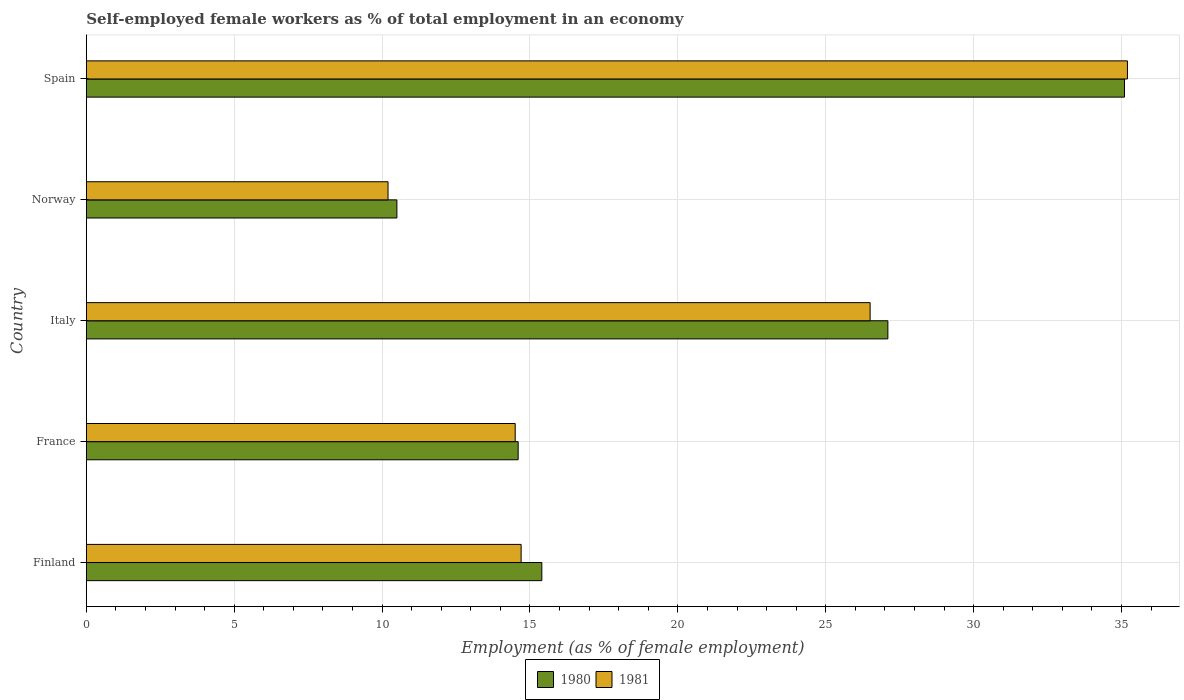How many different coloured bars are there?
Keep it short and to the point. 2. How many bars are there on the 3rd tick from the bottom?
Give a very brief answer. 2. What is the label of the 2nd group of bars from the top?
Give a very brief answer. Norway. In how many cases, is the number of bars for a given country not equal to the number of legend labels?
Your answer should be very brief. 0. What is the percentage of self-employed female workers in 1980 in Finland?
Keep it short and to the point. 15.4. Across all countries, what is the maximum percentage of self-employed female workers in 1981?
Your answer should be very brief. 35.2. Across all countries, what is the minimum percentage of self-employed female workers in 1981?
Provide a succinct answer. 10.2. In which country was the percentage of self-employed female workers in 1980 maximum?
Make the answer very short. Spain. In which country was the percentage of self-employed female workers in 1980 minimum?
Provide a short and direct response. Norway. What is the total percentage of self-employed female workers in 1980 in the graph?
Offer a very short reply. 102.7. What is the difference between the percentage of self-employed female workers in 1980 in France and that in Spain?
Your answer should be very brief. -20.5. What is the difference between the percentage of self-employed female workers in 1981 in Spain and the percentage of self-employed female workers in 1980 in Italy?
Make the answer very short. 8.1. What is the average percentage of self-employed female workers in 1981 per country?
Ensure brevity in your answer.  20.22. What is the difference between the percentage of self-employed female workers in 1980 and percentage of self-employed female workers in 1981 in Italy?
Your answer should be compact. 0.6. What is the ratio of the percentage of self-employed female workers in 1980 in Finland to that in Norway?
Provide a short and direct response. 1.47. Is the difference between the percentage of self-employed female workers in 1980 in France and Spain greater than the difference between the percentage of self-employed female workers in 1981 in France and Spain?
Keep it short and to the point. Yes. What is the difference between the highest and the second highest percentage of self-employed female workers in 1981?
Give a very brief answer. 8.7. What is the difference between the highest and the lowest percentage of self-employed female workers in 1981?
Your answer should be compact. 25. Is the sum of the percentage of self-employed female workers in 1981 in Finland and Italy greater than the maximum percentage of self-employed female workers in 1980 across all countries?
Your answer should be very brief. Yes. What does the 1st bar from the bottom in Italy represents?
Provide a short and direct response. 1980. How many bars are there?
Your answer should be compact. 10. Are all the bars in the graph horizontal?
Make the answer very short. Yes. How many countries are there in the graph?
Offer a terse response. 5. What is the difference between two consecutive major ticks on the X-axis?
Keep it short and to the point. 5. Are the values on the major ticks of X-axis written in scientific E-notation?
Keep it short and to the point. No. How are the legend labels stacked?
Offer a very short reply. Horizontal. What is the title of the graph?
Provide a succinct answer. Self-employed female workers as % of total employment in an economy. Does "1988" appear as one of the legend labels in the graph?
Your response must be concise. No. What is the label or title of the X-axis?
Keep it short and to the point. Employment (as % of female employment). What is the Employment (as % of female employment) of 1980 in Finland?
Your answer should be compact. 15.4. What is the Employment (as % of female employment) of 1981 in Finland?
Keep it short and to the point. 14.7. What is the Employment (as % of female employment) of 1980 in France?
Ensure brevity in your answer.  14.6. What is the Employment (as % of female employment) in 1980 in Italy?
Provide a short and direct response. 27.1. What is the Employment (as % of female employment) of 1981 in Italy?
Ensure brevity in your answer.  26.5. What is the Employment (as % of female employment) of 1980 in Norway?
Provide a succinct answer. 10.5. What is the Employment (as % of female employment) in 1981 in Norway?
Provide a short and direct response. 10.2. What is the Employment (as % of female employment) in 1980 in Spain?
Your answer should be very brief. 35.1. What is the Employment (as % of female employment) in 1981 in Spain?
Offer a very short reply. 35.2. Across all countries, what is the maximum Employment (as % of female employment) in 1980?
Ensure brevity in your answer.  35.1. Across all countries, what is the maximum Employment (as % of female employment) of 1981?
Your response must be concise. 35.2. Across all countries, what is the minimum Employment (as % of female employment) of 1980?
Ensure brevity in your answer.  10.5. Across all countries, what is the minimum Employment (as % of female employment) in 1981?
Keep it short and to the point. 10.2. What is the total Employment (as % of female employment) of 1980 in the graph?
Your answer should be compact. 102.7. What is the total Employment (as % of female employment) in 1981 in the graph?
Provide a succinct answer. 101.1. What is the difference between the Employment (as % of female employment) of 1980 in Finland and that in Spain?
Offer a terse response. -19.7. What is the difference between the Employment (as % of female employment) in 1981 in Finland and that in Spain?
Your answer should be very brief. -20.5. What is the difference between the Employment (as % of female employment) of 1980 in France and that in Italy?
Your answer should be compact. -12.5. What is the difference between the Employment (as % of female employment) in 1981 in France and that in Norway?
Your response must be concise. 4.3. What is the difference between the Employment (as % of female employment) in 1980 in France and that in Spain?
Make the answer very short. -20.5. What is the difference between the Employment (as % of female employment) of 1981 in France and that in Spain?
Offer a very short reply. -20.7. What is the difference between the Employment (as % of female employment) of 1980 in Italy and that in Spain?
Offer a terse response. -8. What is the difference between the Employment (as % of female employment) in 1980 in Norway and that in Spain?
Your answer should be compact. -24.6. What is the difference between the Employment (as % of female employment) in 1981 in Norway and that in Spain?
Provide a succinct answer. -25. What is the difference between the Employment (as % of female employment) of 1980 in Finland and the Employment (as % of female employment) of 1981 in France?
Offer a terse response. 0.9. What is the difference between the Employment (as % of female employment) of 1980 in Finland and the Employment (as % of female employment) of 1981 in Norway?
Provide a short and direct response. 5.2. What is the difference between the Employment (as % of female employment) in 1980 in Finland and the Employment (as % of female employment) in 1981 in Spain?
Give a very brief answer. -19.8. What is the difference between the Employment (as % of female employment) in 1980 in France and the Employment (as % of female employment) in 1981 in Norway?
Give a very brief answer. 4.4. What is the difference between the Employment (as % of female employment) of 1980 in France and the Employment (as % of female employment) of 1981 in Spain?
Make the answer very short. -20.6. What is the difference between the Employment (as % of female employment) in 1980 in Italy and the Employment (as % of female employment) in 1981 in Norway?
Offer a very short reply. 16.9. What is the difference between the Employment (as % of female employment) of 1980 in Italy and the Employment (as % of female employment) of 1981 in Spain?
Provide a short and direct response. -8.1. What is the difference between the Employment (as % of female employment) in 1980 in Norway and the Employment (as % of female employment) in 1981 in Spain?
Your answer should be very brief. -24.7. What is the average Employment (as % of female employment) of 1980 per country?
Provide a succinct answer. 20.54. What is the average Employment (as % of female employment) of 1981 per country?
Offer a terse response. 20.22. What is the difference between the Employment (as % of female employment) in 1980 and Employment (as % of female employment) in 1981 in France?
Provide a succinct answer. 0.1. What is the difference between the Employment (as % of female employment) in 1980 and Employment (as % of female employment) in 1981 in Italy?
Give a very brief answer. 0.6. What is the difference between the Employment (as % of female employment) in 1980 and Employment (as % of female employment) in 1981 in Norway?
Make the answer very short. 0.3. What is the ratio of the Employment (as % of female employment) in 1980 in Finland to that in France?
Give a very brief answer. 1.05. What is the ratio of the Employment (as % of female employment) in 1981 in Finland to that in France?
Offer a terse response. 1.01. What is the ratio of the Employment (as % of female employment) in 1980 in Finland to that in Italy?
Make the answer very short. 0.57. What is the ratio of the Employment (as % of female employment) of 1981 in Finland to that in Italy?
Provide a short and direct response. 0.55. What is the ratio of the Employment (as % of female employment) of 1980 in Finland to that in Norway?
Provide a succinct answer. 1.47. What is the ratio of the Employment (as % of female employment) in 1981 in Finland to that in Norway?
Provide a succinct answer. 1.44. What is the ratio of the Employment (as % of female employment) in 1980 in Finland to that in Spain?
Offer a terse response. 0.44. What is the ratio of the Employment (as % of female employment) in 1981 in Finland to that in Spain?
Offer a very short reply. 0.42. What is the ratio of the Employment (as % of female employment) of 1980 in France to that in Italy?
Provide a short and direct response. 0.54. What is the ratio of the Employment (as % of female employment) of 1981 in France to that in Italy?
Provide a succinct answer. 0.55. What is the ratio of the Employment (as % of female employment) in 1980 in France to that in Norway?
Give a very brief answer. 1.39. What is the ratio of the Employment (as % of female employment) in 1981 in France to that in Norway?
Offer a terse response. 1.42. What is the ratio of the Employment (as % of female employment) in 1980 in France to that in Spain?
Your answer should be very brief. 0.42. What is the ratio of the Employment (as % of female employment) of 1981 in France to that in Spain?
Provide a short and direct response. 0.41. What is the ratio of the Employment (as % of female employment) in 1980 in Italy to that in Norway?
Make the answer very short. 2.58. What is the ratio of the Employment (as % of female employment) in 1981 in Italy to that in Norway?
Offer a very short reply. 2.6. What is the ratio of the Employment (as % of female employment) in 1980 in Italy to that in Spain?
Provide a succinct answer. 0.77. What is the ratio of the Employment (as % of female employment) in 1981 in Italy to that in Spain?
Offer a very short reply. 0.75. What is the ratio of the Employment (as % of female employment) in 1980 in Norway to that in Spain?
Offer a terse response. 0.3. What is the ratio of the Employment (as % of female employment) of 1981 in Norway to that in Spain?
Ensure brevity in your answer.  0.29. What is the difference between the highest and the lowest Employment (as % of female employment) of 1980?
Provide a succinct answer. 24.6. What is the difference between the highest and the lowest Employment (as % of female employment) in 1981?
Your response must be concise. 25. 